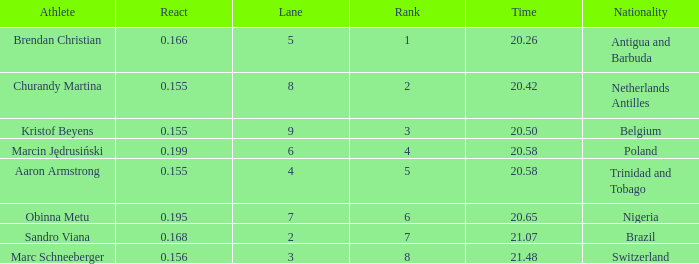Which Lane has a Time larger than 20.5, and a Nationality of trinidad and tobago? 4.0. 